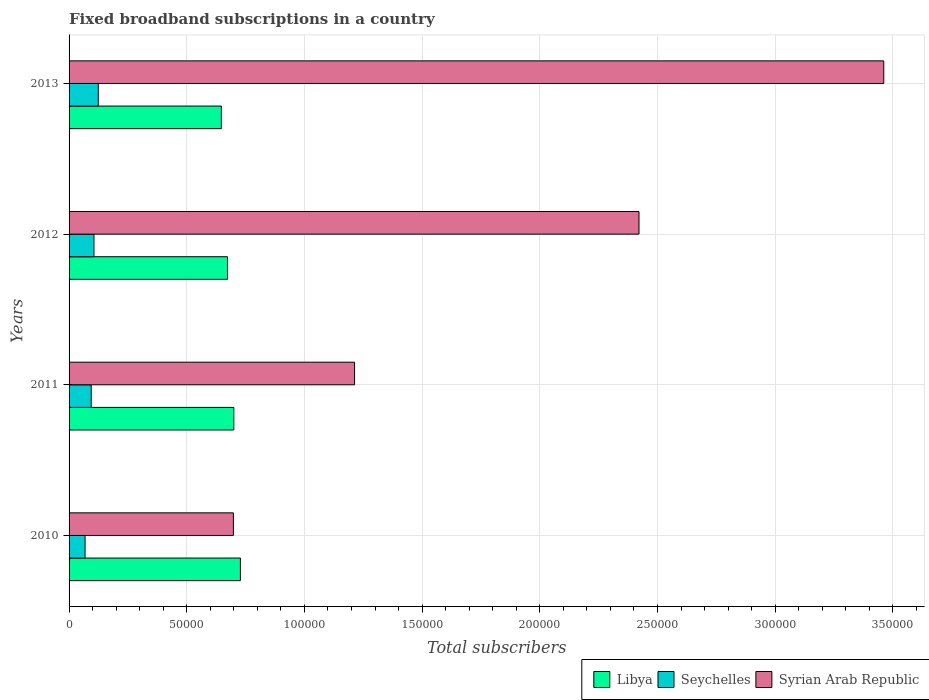How many groups of bars are there?
Ensure brevity in your answer.  4. Are the number of bars per tick equal to the number of legend labels?
Your answer should be very brief. Yes. How many bars are there on the 2nd tick from the bottom?
Provide a short and direct response. 3. What is the number of broadband subscriptions in Syrian Arab Republic in 2010?
Keep it short and to the point. 6.98e+04. Across all years, what is the maximum number of broadband subscriptions in Libya?
Give a very brief answer. 7.28e+04. Across all years, what is the minimum number of broadband subscriptions in Libya?
Make the answer very short. 6.47e+04. What is the total number of broadband subscriptions in Libya in the graph?
Provide a short and direct response. 2.75e+05. What is the difference between the number of broadband subscriptions in Libya in 2011 and that in 2012?
Provide a succinct answer. 2700. What is the difference between the number of broadband subscriptions in Libya in 2013 and the number of broadband subscriptions in Seychelles in 2012?
Give a very brief answer. 5.41e+04. What is the average number of broadband subscriptions in Libya per year?
Your response must be concise. 6.87e+04. In the year 2013, what is the difference between the number of broadband subscriptions in Libya and number of broadband subscriptions in Syrian Arab Republic?
Provide a short and direct response. -2.81e+05. What is the ratio of the number of broadband subscriptions in Syrian Arab Republic in 2010 to that in 2013?
Your response must be concise. 0.2. Is the number of broadband subscriptions in Seychelles in 2010 less than that in 2011?
Offer a very short reply. Yes. What is the difference between the highest and the second highest number of broadband subscriptions in Syrian Arab Republic?
Offer a very short reply. 1.04e+05. What is the difference between the highest and the lowest number of broadband subscriptions in Libya?
Offer a terse response. 8100. What does the 3rd bar from the top in 2010 represents?
Your answer should be very brief. Libya. What does the 1st bar from the bottom in 2013 represents?
Give a very brief answer. Libya. How many years are there in the graph?
Offer a very short reply. 4. Are the values on the major ticks of X-axis written in scientific E-notation?
Give a very brief answer. No. Where does the legend appear in the graph?
Offer a very short reply. Bottom right. How are the legend labels stacked?
Give a very brief answer. Horizontal. What is the title of the graph?
Keep it short and to the point. Fixed broadband subscriptions in a country. Does "High income" appear as one of the legend labels in the graph?
Your answer should be very brief. No. What is the label or title of the X-axis?
Keep it short and to the point. Total subscribers. What is the Total subscribers of Libya in 2010?
Your answer should be compact. 7.28e+04. What is the Total subscribers in Seychelles in 2010?
Offer a terse response. 6793. What is the Total subscribers of Syrian Arab Republic in 2010?
Your answer should be very brief. 6.98e+04. What is the Total subscribers of Seychelles in 2011?
Your answer should be very brief. 9412. What is the Total subscribers in Syrian Arab Republic in 2011?
Provide a short and direct response. 1.21e+05. What is the Total subscribers of Libya in 2012?
Give a very brief answer. 6.73e+04. What is the Total subscribers of Seychelles in 2012?
Your answer should be compact. 1.06e+04. What is the Total subscribers of Syrian Arab Republic in 2012?
Your response must be concise. 2.42e+05. What is the Total subscribers in Libya in 2013?
Provide a succinct answer. 6.47e+04. What is the Total subscribers of Seychelles in 2013?
Your response must be concise. 1.24e+04. What is the Total subscribers of Syrian Arab Republic in 2013?
Provide a short and direct response. 3.46e+05. Across all years, what is the maximum Total subscribers of Libya?
Offer a terse response. 7.28e+04. Across all years, what is the maximum Total subscribers in Seychelles?
Offer a terse response. 1.24e+04. Across all years, what is the maximum Total subscribers of Syrian Arab Republic?
Provide a succinct answer. 3.46e+05. Across all years, what is the minimum Total subscribers of Libya?
Ensure brevity in your answer.  6.47e+04. Across all years, what is the minimum Total subscribers of Seychelles?
Offer a very short reply. 6793. Across all years, what is the minimum Total subscribers of Syrian Arab Republic?
Provide a short and direct response. 6.98e+04. What is the total Total subscribers of Libya in the graph?
Provide a succinct answer. 2.75e+05. What is the total Total subscribers in Seychelles in the graph?
Provide a succinct answer. 3.92e+04. What is the total Total subscribers of Syrian Arab Republic in the graph?
Offer a terse response. 7.79e+05. What is the difference between the Total subscribers in Libya in 2010 and that in 2011?
Keep it short and to the point. 2800. What is the difference between the Total subscribers of Seychelles in 2010 and that in 2011?
Keep it short and to the point. -2619. What is the difference between the Total subscribers of Syrian Arab Republic in 2010 and that in 2011?
Make the answer very short. -5.15e+04. What is the difference between the Total subscribers in Libya in 2010 and that in 2012?
Keep it short and to the point. 5500. What is the difference between the Total subscribers in Seychelles in 2010 and that in 2012?
Your answer should be compact. -3784. What is the difference between the Total subscribers in Syrian Arab Republic in 2010 and that in 2012?
Your answer should be compact. -1.72e+05. What is the difference between the Total subscribers of Libya in 2010 and that in 2013?
Provide a succinct answer. 8100. What is the difference between the Total subscribers of Seychelles in 2010 and that in 2013?
Offer a terse response. -5618. What is the difference between the Total subscribers in Syrian Arab Republic in 2010 and that in 2013?
Offer a terse response. -2.76e+05. What is the difference between the Total subscribers of Libya in 2011 and that in 2012?
Make the answer very short. 2700. What is the difference between the Total subscribers of Seychelles in 2011 and that in 2012?
Your answer should be compact. -1165. What is the difference between the Total subscribers of Syrian Arab Republic in 2011 and that in 2012?
Your answer should be compact. -1.21e+05. What is the difference between the Total subscribers of Libya in 2011 and that in 2013?
Keep it short and to the point. 5300. What is the difference between the Total subscribers in Seychelles in 2011 and that in 2013?
Give a very brief answer. -2999. What is the difference between the Total subscribers in Syrian Arab Republic in 2011 and that in 2013?
Provide a succinct answer. -2.25e+05. What is the difference between the Total subscribers of Libya in 2012 and that in 2013?
Offer a very short reply. 2600. What is the difference between the Total subscribers of Seychelles in 2012 and that in 2013?
Ensure brevity in your answer.  -1834. What is the difference between the Total subscribers in Syrian Arab Republic in 2012 and that in 2013?
Provide a short and direct response. -1.04e+05. What is the difference between the Total subscribers of Libya in 2010 and the Total subscribers of Seychelles in 2011?
Your answer should be compact. 6.34e+04. What is the difference between the Total subscribers of Libya in 2010 and the Total subscribers of Syrian Arab Republic in 2011?
Your answer should be compact. -4.85e+04. What is the difference between the Total subscribers of Seychelles in 2010 and the Total subscribers of Syrian Arab Republic in 2011?
Provide a succinct answer. -1.15e+05. What is the difference between the Total subscribers in Libya in 2010 and the Total subscribers in Seychelles in 2012?
Provide a short and direct response. 6.22e+04. What is the difference between the Total subscribers of Libya in 2010 and the Total subscribers of Syrian Arab Republic in 2012?
Offer a terse response. -1.69e+05. What is the difference between the Total subscribers of Seychelles in 2010 and the Total subscribers of Syrian Arab Republic in 2012?
Offer a very short reply. -2.35e+05. What is the difference between the Total subscribers in Libya in 2010 and the Total subscribers in Seychelles in 2013?
Offer a terse response. 6.04e+04. What is the difference between the Total subscribers in Libya in 2010 and the Total subscribers in Syrian Arab Republic in 2013?
Offer a terse response. -2.73e+05. What is the difference between the Total subscribers in Seychelles in 2010 and the Total subscribers in Syrian Arab Republic in 2013?
Your answer should be compact. -3.39e+05. What is the difference between the Total subscribers in Libya in 2011 and the Total subscribers in Seychelles in 2012?
Your response must be concise. 5.94e+04. What is the difference between the Total subscribers of Libya in 2011 and the Total subscribers of Syrian Arab Republic in 2012?
Your response must be concise. -1.72e+05. What is the difference between the Total subscribers of Seychelles in 2011 and the Total subscribers of Syrian Arab Republic in 2012?
Give a very brief answer. -2.33e+05. What is the difference between the Total subscribers in Libya in 2011 and the Total subscribers in Seychelles in 2013?
Ensure brevity in your answer.  5.76e+04. What is the difference between the Total subscribers in Libya in 2011 and the Total subscribers in Syrian Arab Republic in 2013?
Your answer should be compact. -2.76e+05. What is the difference between the Total subscribers of Seychelles in 2011 and the Total subscribers of Syrian Arab Republic in 2013?
Keep it short and to the point. -3.37e+05. What is the difference between the Total subscribers of Libya in 2012 and the Total subscribers of Seychelles in 2013?
Offer a very short reply. 5.49e+04. What is the difference between the Total subscribers in Libya in 2012 and the Total subscribers in Syrian Arab Republic in 2013?
Provide a short and direct response. -2.79e+05. What is the difference between the Total subscribers in Seychelles in 2012 and the Total subscribers in Syrian Arab Republic in 2013?
Give a very brief answer. -3.36e+05. What is the average Total subscribers of Libya per year?
Provide a short and direct response. 6.87e+04. What is the average Total subscribers in Seychelles per year?
Make the answer very short. 9798.25. What is the average Total subscribers in Syrian Arab Republic per year?
Ensure brevity in your answer.  1.95e+05. In the year 2010, what is the difference between the Total subscribers of Libya and Total subscribers of Seychelles?
Give a very brief answer. 6.60e+04. In the year 2010, what is the difference between the Total subscribers in Libya and Total subscribers in Syrian Arab Republic?
Your answer should be very brief. 2983. In the year 2010, what is the difference between the Total subscribers in Seychelles and Total subscribers in Syrian Arab Republic?
Give a very brief answer. -6.30e+04. In the year 2011, what is the difference between the Total subscribers of Libya and Total subscribers of Seychelles?
Your response must be concise. 6.06e+04. In the year 2011, what is the difference between the Total subscribers in Libya and Total subscribers in Syrian Arab Republic?
Provide a short and direct response. -5.13e+04. In the year 2011, what is the difference between the Total subscribers in Seychelles and Total subscribers in Syrian Arab Republic?
Your answer should be compact. -1.12e+05. In the year 2012, what is the difference between the Total subscribers in Libya and Total subscribers in Seychelles?
Provide a succinct answer. 5.67e+04. In the year 2012, what is the difference between the Total subscribers in Libya and Total subscribers in Syrian Arab Republic?
Your answer should be very brief. -1.75e+05. In the year 2012, what is the difference between the Total subscribers in Seychelles and Total subscribers in Syrian Arab Republic?
Offer a very short reply. -2.32e+05. In the year 2013, what is the difference between the Total subscribers of Libya and Total subscribers of Seychelles?
Keep it short and to the point. 5.23e+04. In the year 2013, what is the difference between the Total subscribers in Libya and Total subscribers in Syrian Arab Republic?
Keep it short and to the point. -2.81e+05. In the year 2013, what is the difference between the Total subscribers of Seychelles and Total subscribers of Syrian Arab Republic?
Keep it short and to the point. -3.34e+05. What is the ratio of the Total subscribers of Libya in 2010 to that in 2011?
Make the answer very short. 1.04. What is the ratio of the Total subscribers of Seychelles in 2010 to that in 2011?
Ensure brevity in your answer.  0.72. What is the ratio of the Total subscribers of Syrian Arab Republic in 2010 to that in 2011?
Provide a succinct answer. 0.58. What is the ratio of the Total subscribers in Libya in 2010 to that in 2012?
Make the answer very short. 1.08. What is the ratio of the Total subscribers in Seychelles in 2010 to that in 2012?
Your answer should be compact. 0.64. What is the ratio of the Total subscribers in Syrian Arab Republic in 2010 to that in 2012?
Ensure brevity in your answer.  0.29. What is the ratio of the Total subscribers of Libya in 2010 to that in 2013?
Keep it short and to the point. 1.13. What is the ratio of the Total subscribers in Seychelles in 2010 to that in 2013?
Ensure brevity in your answer.  0.55. What is the ratio of the Total subscribers in Syrian Arab Republic in 2010 to that in 2013?
Your answer should be compact. 0.2. What is the ratio of the Total subscribers in Libya in 2011 to that in 2012?
Your answer should be very brief. 1.04. What is the ratio of the Total subscribers of Seychelles in 2011 to that in 2012?
Provide a short and direct response. 0.89. What is the ratio of the Total subscribers of Syrian Arab Republic in 2011 to that in 2012?
Ensure brevity in your answer.  0.5. What is the ratio of the Total subscribers of Libya in 2011 to that in 2013?
Give a very brief answer. 1.08. What is the ratio of the Total subscribers in Seychelles in 2011 to that in 2013?
Provide a succinct answer. 0.76. What is the ratio of the Total subscribers in Syrian Arab Republic in 2011 to that in 2013?
Your answer should be compact. 0.35. What is the ratio of the Total subscribers of Libya in 2012 to that in 2013?
Ensure brevity in your answer.  1.04. What is the ratio of the Total subscribers of Seychelles in 2012 to that in 2013?
Offer a terse response. 0.85. What is the ratio of the Total subscribers in Syrian Arab Republic in 2012 to that in 2013?
Your response must be concise. 0.7. What is the difference between the highest and the second highest Total subscribers in Libya?
Give a very brief answer. 2800. What is the difference between the highest and the second highest Total subscribers in Seychelles?
Provide a short and direct response. 1834. What is the difference between the highest and the second highest Total subscribers in Syrian Arab Republic?
Offer a terse response. 1.04e+05. What is the difference between the highest and the lowest Total subscribers in Libya?
Offer a terse response. 8100. What is the difference between the highest and the lowest Total subscribers of Seychelles?
Your response must be concise. 5618. What is the difference between the highest and the lowest Total subscribers of Syrian Arab Republic?
Your answer should be very brief. 2.76e+05. 